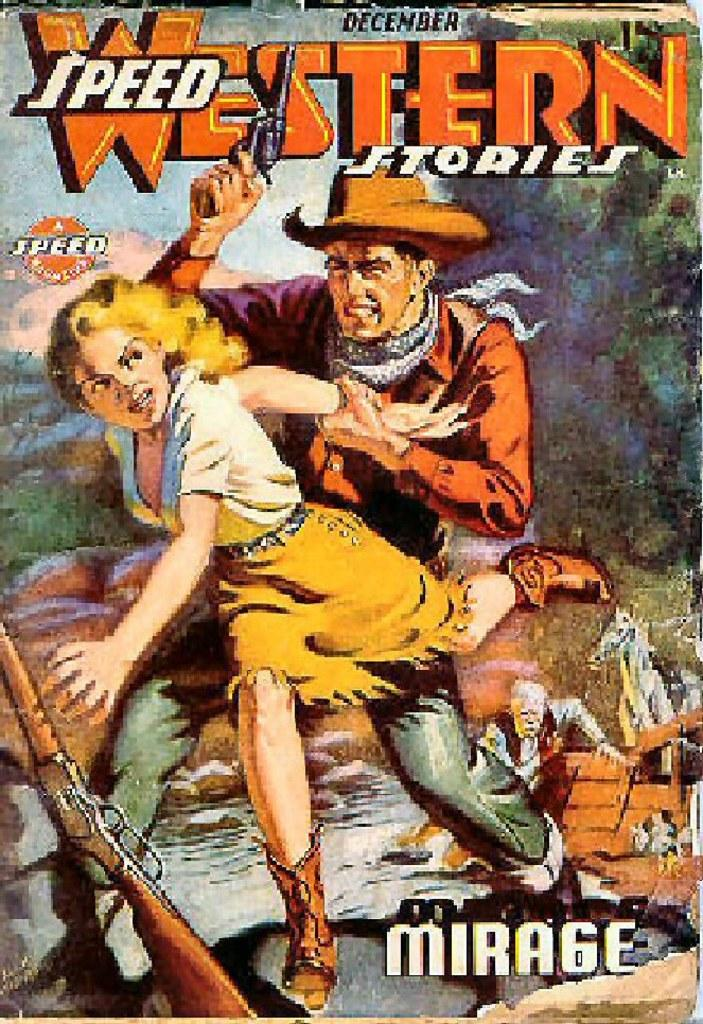<image>
Write a terse but informative summary of the picture. Western speed stories mirage book with lady grabbing a gun 